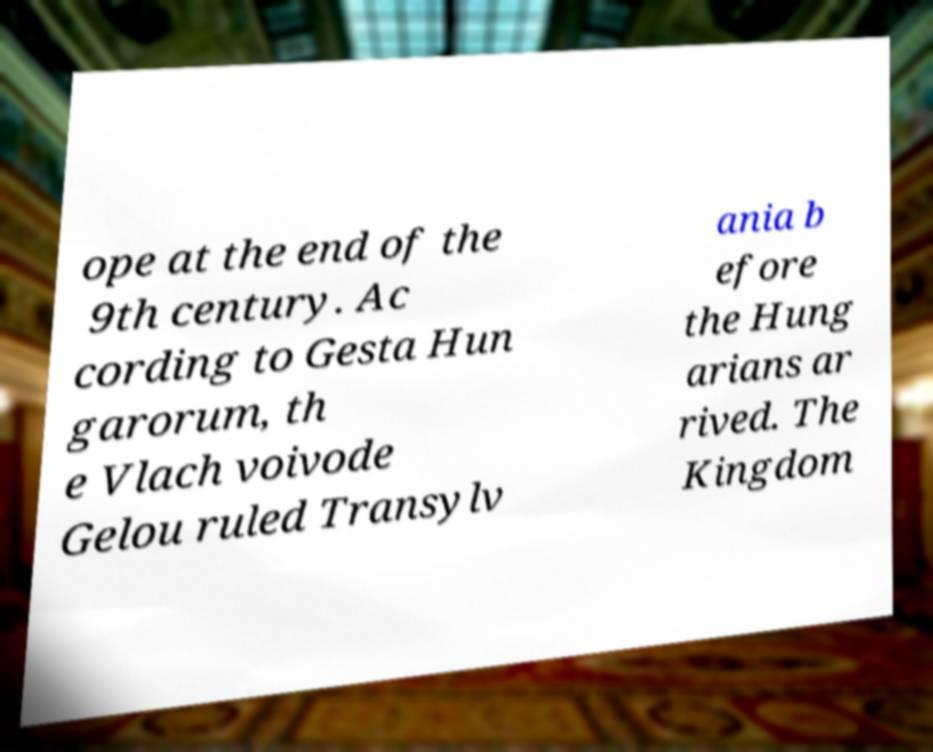Could you extract and type out the text from this image? ope at the end of the 9th century. Ac cording to Gesta Hun garorum, th e Vlach voivode Gelou ruled Transylv ania b efore the Hung arians ar rived. The Kingdom 